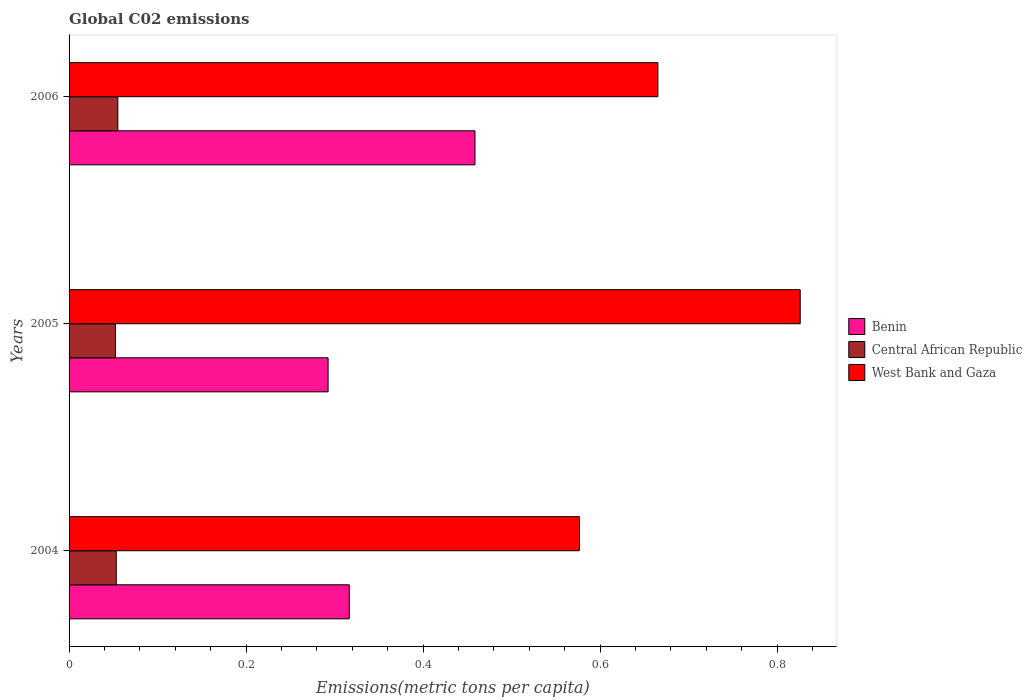How many different coloured bars are there?
Your answer should be very brief. 3. How many groups of bars are there?
Your response must be concise. 3. Are the number of bars on each tick of the Y-axis equal?
Your response must be concise. Yes. How many bars are there on the 1st tick from the top?
Give a very brief answer. 3. In how many cases, is the number of bars for a given year not equal to the number of legend labels?
Make the answer very short. 0. What is the amount of CO2 emitted in in West Bank and Gaza in 2006?
Your response must be concise. 0.67. Across all years, what is the maximum amount of CO2 emitted in in Central African Republic?
Ensure brevity in your answer.  0.06. Across all years, what is the minimum amount of CO2 emitted in in Central African Republic?
Your answer should be very brief. 0.05. What is the total amount of CO2 emitted in in Central African Republic in the graph?
Ensure brevity in your answer.  0.16. What is the difference between the amount of CO2 emitted in in Central African Republic in 2004 and that in 2006?
Your response must be concise. -0. What is the difference between the amount of CO2 emitted in in Central African Republic in 2006 and the amount of CO2 emitted in in Benin in 2005?
Offer a very short reply. -0.24. What is the average amount of CO2 emitted in in Benin per year?
Your response must be concise. 0.36. In the year 2006, what is the difference between the amount of CO2 emitted in in Central African Republic and amount of CO2 emitted in in West Bank and Gaza?
Offer a terse response. -0.61. What is the ratio of the amount of CO2 emitted in in Benin in 2004 to that in 2006?
Offer a terse response. 0.69. Is the difference between the amount of CO2 emitted in in Central African Republic in 2004 and 2006 greater than the difference between the amount of CO2 emitted in in West Bank and Gaza in 2004 and 2006?
Provide a short and direct response. Yes. What is the difference between the highest and the second highest amount of CO2 emitted in in West Bank and Gaza?
Provide a short and direct response. 0.16. What is the difference between the highest and the lowest amount of CO2 emitted in in West Bank and Gaza?
Your response must be concise. 0.25. In how many years, is the amount of CO2 emitted in in Central African Republic greater than the average amount of CO2 emitted in in Central African Republic taken over all years?
Your answer should be very brief. 1. What does the 2nd bar from the top in 2006 represents?
Your answer should be very brief. Central African Republic. What does the 2nd bar from the bottom in 2006 represents?
Your answer should be compact. Central African Republic. Are all the bars in the graph horizontal?
Provide a short and direct response. Yes. How many years are there in the graph?
Keep it short and to the point. 3. What is the difference between two consecutive major ticks on the X-axis?
Offer a very short reply. 0.2. Does the graph contain grids?
Keep it short and to the point. No. Where does the legend appear in the graph?
Make the answer very short. Center right. How many legend labels are there?
Keep it short and to the point. 3. What is the title of the graph?
Offer a very short reply. Global C02 emissions. What is the label or title of the X-axis?
Keep it short and to the point. Emissions(metric tons per capita). What is the label or title of the Y-axis?
Make the answer very short. Years. What is the Emissions(metric tons per capita) of Benin in 2004?
Offer a terse response. 0.32. What is the Emissions(metric tons per capita) of Central African Republic in 2004?
Your answer should be compact. 0.05. What is the Emissions(metric tons per capita) of West Bank and Gaza in 2004?
Keep it short and to the point. 0.58. What is the Emissions(metric tons per capita) in Benin in 2005?
Ensure brevity in your answer.  0.29. What is the Emissions(metric tons per capita) in Central African Republic in 2005?
Your response must be concise. 0.05. What is the Emissions(metric tons per capita) in West Bank and Gaza in 2005?
Your answer should be compact. 0.83. What is the Emissions(metric tons per capita) in Benin in 2006?
Keep it short and to the point. 0.46. What is the Emissions(metric tons per capita) in Central African Republic in 2006?
Provide a short and direct response. 0.06. What is the Emissions(metric tons per capita) of West Bank and Gaza in 2006?
Make the answer very short. 0.67. Across all years, what is the maximum Emissions(metric tons per capita) in Benin?
Offer a very short reply. 0.46. Across all years, what is the maximum Emissions(metric tons per capita) in Central African Republic?
Make the answer very short. 0.06. Across all years, what is the maximum Emissions(metric tons per capita) in West Bank and Gaza?
Your response must be concise. 0.83. Across all years, what is the minimum Emissions(metric tons per capita) in Benin?
Ensure brevity in your answer.  0.29. Across all years, what is the minimum Emissions(metric tons per capita) in Central African Republic?
Provide a short and direct response. 0.05. Across all years, what is the minimum Emissions(metric tons per capita) of West Bank and Gaza?
Provide a short and direct response. 0.58. What is the total Emissions(metric tons per capita) in Benin in the graph?
Keep it short and to the point. 1.07. What is the total Emissions(metric tons per capita) of Central African Republic in the graph?
Provide a succinct answer. 0.16. What is the total Emissions(metric tons per capita) in West Bank and Gaza in the graph?
Provide a short and direct response. 2.07. What is the difference between the Emissions(metric tons per capita) in Benin in 2004 and that in 2005?
Offer a terse response. 0.02. What is the difference between the Emissions(metric tons per capita) in Central African Republic in 2004 and that in 2005?
Provide a short and direct response. 0. What is the difference between the Emissions(metric tons per capita) of West Bank and Gaza in 2004 and that in 2005?
Offer a terse response. -0.25. What is the difference between the Emissions(metric tons per capita) in Benin in 2004 and that in 2006?
Ensure brevity in your answer.  -0.14. What is the difference between the Emissions(metric tons per capita) of Central African Republic in 2004 and that in 2006?
Give a very brief answer. -0. What is the difference between the Emissions(metric tons per capita) of West Bank and Gaza in 2004 and that in 2006?
Your answer should be very brief. -0.09. What is the difference between the Emissions(metric tons per capita) of Benin in 2005 and that in 2006?
Provide a succinct answer. -0.17. What is the difference between the Emissions(metric tons per capita) in Central African Republic in 2005 and that in 2006?
Keep it short and to the point. -0. What is the difference between the Emissions(metric tons per capita) in West Bank and Gaza in 2005 and that in 2006?
Ensure brevity in your answer.  0.16. What is the difference between the Emissions(metric tons per capita) in Benin in 2004 and the Emissions(metric tons per capita) in Central African Republic in 2005?
Make the answer very short. 0.26. What is the difference between the Emissions(metric tons per capita) in Benin in 2004 and the Emissions(metric tons per capita) in West Bank and Gaza in 2005?
Your answer should be very brief. -0.51. What is the difference between the Emissions(metric tons per capita) of Central African Republic in 2004 and the Emissions(metric tons per capita) of West Bank and Gaza in 2005?
Give a very brief answer. -0.77. What is the difference between the Emissions(metric tons per capita) of Benin in 2004 and the Emissions(metric tons per capita) of Central African Republic in 2006?
Make the answer very short. 0.26. What is the difference between the Emissions(metric tons per capita) of Benin in 2004 and the Emissions(metric tons per capita) of West Bank and Gaza in 2006?
Keep it short and to the point. -0.35. What is the difference between the Emissions(metric tons per capita) in Central African Republic in 2004 and the Emissions(metric tons per capita) in West Bank and Gaza in 2006?
Make the answer very short. -0.61. What is the difference between the Emissions(metric tons per capita) in Benin in 2005 and the Emissions(metric tons per capita) in Central African Republic in 2006?
Offer a very short reply. 0.24. What is the difference between the Emissions(metric tons per capita) in Benin in 2005 and the Emissions(metric tons per capita) in West Bank and Gaza in 2006?
Give a very brief answer. -0.37. What is the difference between the Emissions(metric tons per capita) of Central African Republic in 2005 and the Emissions(metric tons per capita) of West Bank and Gaza in 2006?
Ensure brevity in your answer.  -0.61. What is the average Emissions(metric tons per capita) in Benin per year?
Provide a short and direct response. 0.36. What is the average Emissions(metric tons per capita) of Central African Republic per year?
Keep it short and to the point. 0.05. What is the average Emissions(metric tons per capita) in West Bank and Gaza per year?
Your answer should be compact. 0.69. In the year 2004, what is the difference between the Emissions(metric tons per capita) of Benin and Emissions(metric tons per capita) of Central African Republic?
Your answer should be compact. 0.26. In the year 2004, what is the difference between the Emissions(metric tons per capita) of Benin and Emissions(metric tons per capita) of West Bank and Gaza?
Your response must be concise. -0.26. In the year 2004, what is the difference between the Emissions(metric tons per capita) of Central African Republic and Emissions(metric tons per capita) of West Bank and Gaza?
Provide a short and direct response. -0.52. In the year 2005, what is the difference between the Emissions(metric tons per capita) in Benin and Emissions(metric tons per capita) in Central African Republic?
Your answer should be very brief. 0.24. In the year 2005, what is the difference between the Emissions(metric tons per capita) of Benin and Emissions(metric tons per capita) of West Bank and Gaza?
Keep it short and to the point. -0.53. In the year 2005, what is the difference between the Emissions(metric tons per capita) of Central African Republic and Emissions(metric tons per capita) of West Bank and Gaza?
Offer a very short reply. -0.77. In the year 2006, what is the difference between the Emissions(metric tons per capita) of Benin and Emissions(metric tons per capita) of Central African Republic?
Your answer should be very brief. 0.4. In the year 2006, what is the difference between the Emissions(metric tons per capita) of Benin and Emissions(metric tons per capita) of West Bank and Gaza?
Your response must be concise. -0.21. In the year 2006, what is the difference between the Emissions(metric tons per capita) in Central African Republic and Emissions(metric tons per capita) in West Bank and Gaza?
Provide a short and direct response. -0.61. What is the ratio of the Emissions(metric tons per capita) of Benin in 2004 to that in 2005?
Offer a very short reply. 1.08. What is the ratio of the Emissions(metric tons per capita) of West Bank and Gaza in 2004 to that in 2005?
Your response must be concise. 0.7. What is the ratio of the Emissions(metric tons per capita) of Benin in 2004 to that in 2006?
Provide a short and direct response. 0.69. What is the ratio of the Emissions(metric tons per capita) of Central African Republic in 2004 to that in 2006?
Keep it short and to the point. 0.97. What is the ratio of the Emissions(metric tons per capita) in West Bank and Gaza in 2004 to that in 2006?
Provide a succinct answer. 0.87. What is the ratio of the Emissions(metric tons per capita) in Benin in 2005 to that in 2006?
Ensure brevity in your answer.  0.64. What is the ratio of the Emissions(metric tons per capita) of Central African Republic in 2005 to that in 2006?
Your answer should be very brief. 0.95. What is the ratio of the Emissions(metric tons per capita) of West Bank and Gaza in 2005 to that in 2006?
Your answer should be compact. 1.24. What is the difference between the highest and the second highest Emissions(metric tons per capita) of Benin?
Ensure brevity in your answer.  0.14. What is the difference between the highest and the second highest Emissions(metric tons per capita) in Central African Republic?
Keep it short and to the point. 0. What is the difference between the highest and the second highest Emissions(metric tons per capita) in West Bank and Gaza?
Your answer should be compact. 0.16. What is the difference between the highest and the lowest Emissions(metric tons per capita) of Benin?
Offer a very short reply. 0.17. What is the difference between the highest and the lowest Emissions(metric tons per capita) in Central African Republic?
Your answer should be compact. 0. What is the difference between the highest and the lowest Emissions(metric tons per capita) of West Bank and Gaza?
Keep it short and to the point. 0.25. 